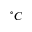<formula> <loc_0><loc_0><loc_500><loc_500>^ { \circ } C</formula> 